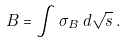<formula> <loc_0><loc_0><loc_500><loc_500>B = \int \sigma _ { B } \, d \sqrt { s } \, .</formula> 